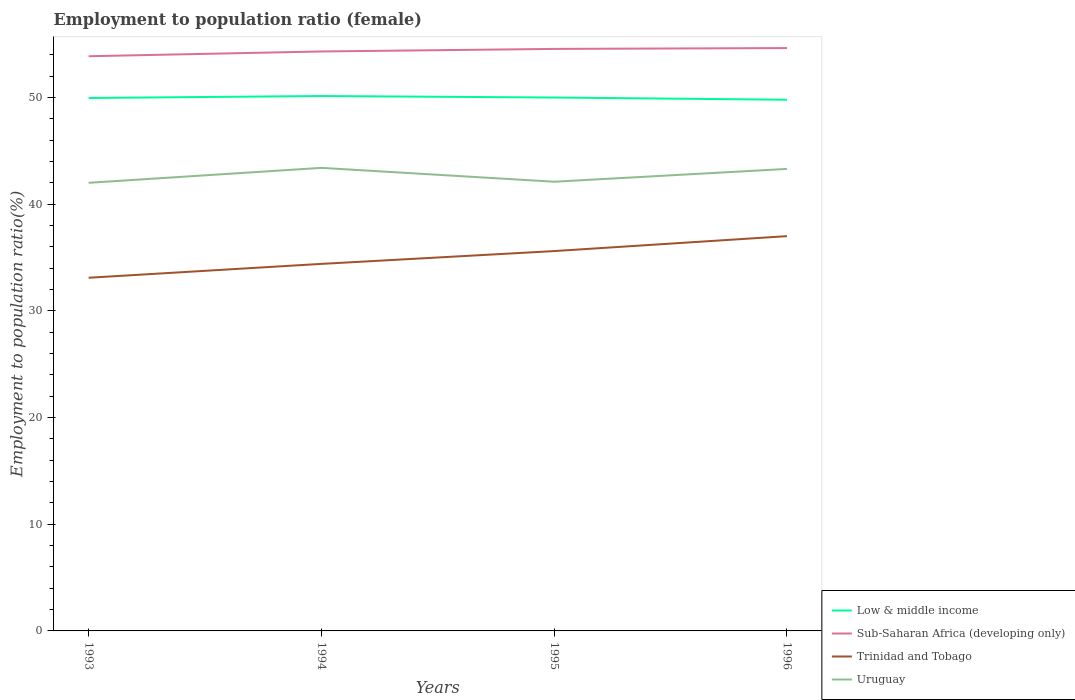Does the line corresponding to Sub-Saharan Africa (developing only) intersect with the line corresponding to Trinidad and Tobago?
Provide a short and direct response. No. Across all years, what is the maximum employment to population ratio in Trinidad and Tobago?
Your response must be concise. 33.1. What is the total employment to population ratio in Trinidad and Tobago in the graph?
Keep it short and to the point. -2.6. What is the difference between the highest and the second highest employment to population ratio in Uruguay?
Provide a succinct answer. 1.4. What is the difference between the highest and the lowest employment to population ratio in Sub-Saharan Africa (developing only)?
Your response must be concise. 2. What is the title of the graph?
Make the answer very short. Employment to population ratio (female). Does "Ukraine" appear as one of the legend labels in the graph?
Offer a very short reply. No. What is the label or title of the Y-axis?
Your answer should be compact. Employment to population ratio(%). What is the Employment to population ratio(%) of Low & middle income in 1993?
Ensure brevity in your answer.  49.95. What is the Employment to population ratio(%) of Sub-Saharan Africa (developing only) in 1993?
Give a very brief answer. 53.86. What is the Employment to population ratio(%) of Trinidad and Tobago in 1993?
Make the answer very short. 33.1. What is the Employment to population ratio(%) of Low & middle income in 1994?
Give a very brief answer. 50.13. What is the Employment to population ratio(%) of Sub-Saharan Africa (developing only) in 1994?
Your answer should be compact. 54.31. What is the Employment to population ratio(%) of Trinidad and Tobago in 1994?
Your response must be concise. 34.4. What is the Employment to population ratio(%) of Uruguay in 1994?
Keep it short and to the point. 43.4. What is the Employment to population ratio(%) in Low & middle income in 1995?
Your answer should be very brief. 49.99. What is the Employment to population ratio(%) of Sub-Saharan Africa (developing only) in 1995?
Keep it short and to the point. 54.55. What is the Employment to population ratio(%) in Trinidad and Tobago in 1995?
Offer a very short reply. 35.6. What is the Employment to population ratio(%) of Uruguay in 1995?
Provide a succinct answer. 42.1. What is the Employment to population ratio(%) of Low & middle income in 1996?
Offer a terse response. 49.79. What is the Employment to population ratio(%) of Sub-Saharan Africa (developing only) in 1996?
Provide a short and direct response. 54.63. What is the Employment to population ratio(%) in Trinidad and Tobago in 1996?
Ensure brevity in your answer.  37. What is the Employment to population ratio(%) in Uruguay in 1996?
Provide a short and direct response. 43.3. Across all years, what is the maximum Employment to population ratio(%) of Low & middle income?
Your answer should be very brief. 50.13. Across all years, what is the maximum Employment to population ratio(%) of Sub-Saharan Africa (developing only)?
Your answer should be compact. 54.63. Across all years, what is the maximum Employment to population ratio(%) of Trinidad and Tobago?
Your answer should be compact. 37. Across all years, what is the maximum Employment to population ratio(%) of Uruguay?
Your answer should be compact. 43.4. Across all years, what is the minimum Employment to population ratio(%) in Low & middle income?
Ensure brevity in your answer.  49.79. Across all years, what is the minimum Employment to population ratio(%) of Sub-Saharan Africa (developing only)?
Ensure brevity in your answer.  53.86. Across all years, what is the minimum Employment to population ratio(%) of Trinidad and Tobago?
Your response must be concise. 33.1. What is the total Employment to population ratio(%) of Low & middle income in the graph?
Keep it short and to the point. 199.86. What is the total Employment to population ratio(%) of Sub-Saharan Africa (developing only) in the graph?
Your answer should be very brief. 217.35. What is the total Employment to population ratio(%) of Trinidad and Tobago in the graph?
Offer a very short reply. 140.1. What is the total Employment to population ratio(%) of Uruguay in the graph?
Ensure brevity in your answer.  170.8. What is the difference between the Employment to population ratio(%) in Low & middle income in 1993 and that in 1994?
Give a very brief answer. -0.18. What is the difference between the Employment to population ratio(%) in Sub-Saharan Africa (developing only) in 1993 and that in 1994?
Give a very brief answer. -0.45. What is the difference between the Employment to population ratio(%) of Low & middle income in 1993 and that in 1995?
Your answer should be compact. -0.04. What is the difference between the Employment to population ratio(%) of Sub-Saharan Africa (developing only) in 1993 and that in 1995?
Your answer should be very brief. -0.69. What is the difference between the Employment to population ratio(%) in Low & middle income in 1993 and that in 1996?
Make the answer very short. 0.16. What is the difference between the Employment to population ratio(%) in Sub-Saharan Africa (developing only) in 1993 and that in 1996?
Keep it short and to the point. -0.77. What is the difference between the Employment to population ratio(%) of Trinidad and Tobago in 1993 and that in 1996?
Ensure brevity in your answer.  -3.9. What is the difference between the Employment to population ratio(%) in Low & middle income in 1994 and that in 1995?
Your answer should be compact. 0.14. What is the difference between the Employment to population ratio(%) in Sub-Saharan Africa (developing only) in 1994 and that in 1995?
Provide a short and direct response. -0.24. What is the difference between the Employment to population ratio(%) in Uruguay in 1994 and that in 1995?
Provide a succinct answer. 1.3. What is the difference between the Employment to population ratio(%) in Low & middle income in 1994 and that in 1996?
Offer a very short reply. 0.35. What is the difference between the Employment to population ratio(%) in Sub-Saharan Africa (developing only) in 1994 and that in 1996?
Your answer should be very brief. -0.32. What is the difference between the Employment to population ratio(%) of Uruguay in 1994 and that in 1996?
Offer a very short reply. 0.1. What is the difference between the Employment to population ratio(%) of Low & middle income in 1995 and that in 1996?
Your answer should be very brief. 0.21. What is the difference between the Employment to population ratio(%) in Sub-Saharan Africa (developing only) in 1995 and that in 1996?
Provide a succinct answer. -0.08. What is the difference between the Employment to population ratio(%) of Low & middle income in 1993 and the Employment to population ratio(%) of Sub-Saharan Africa (developing only) in 1994?
Keep it short and to the point. -4.36. What is the difference between the Employment to population ratio(%) in Low & middle income in 1993 and the Employment to population ratio(%) in Trinidad and Tobago in 1994?
Give a very brief answer. 15.55. What is the difference between the Employment to population ratio(%) of Low & middle income in 1993 and the Employment to population ratio(%) of Uruguay in 1994?
Your answer should be very brief. 6.55. What is the difference between the Employment to population ratio(%) of Sub-Saharan Africa (developing only) in 1993 and the Employment to population ratio(%) of Trinidad and Tobago in 1994?
Keep it short and to the point. 19.46. What is the difference between the Employment to population ratio(%) in Sub-Saharan Africa (developing only) in 1993 and the Employment to population ratio(%) in Uruguay in 1994?
Offer a terse response. 10.46. What is the difference between the Employment to population ratio(%) in Low & middle income in 1993 and the Employment to population ratio(%) in Sub-Saharan Africa (developing only) in 1995?
Your response must be concise. -4.6. What is the difference between the Employment to population ratio(%) of Low & middle income in 1993 and the Employment to population ratio(%) of Trinidad and Tobago in 1995?
Your response must be concise. 14.35. What is the difference between the Employment to population ratio(%) of Low & middle income in 1993 and the Employment to population ratio(%) of Uruguay in 1995?
Ensure brevity in your answer.  7.85. What is the difference between the Employment to population ratio(%) of Sub-Saharan Africa (developing only) in 1993 and the Employment to population ratio(%) of Trinidad and Tobago in 1995?
Offer a very short reply. 18.26. What is the difference between the Employment to population ratio(%) of Sub-Saharan Africa (developing only) in 1993 and the Employment to population ratio(%) of Uruguay in 1995?
Make the answer very short. 11.76. What is the difference between the Employment to population ratio(%) in Low & middle income in 1993 and the Employment to population ratio(%) in Sub-Saharan Africa (developing only) in 1996?
Make the answer very short. -4.68. What is the difference between the Employment to population ratio(%) of Low & middle income in 1993 and the Employment to population ratio(%) of Trinidad and Tobago in 1996?
Ensure brevity in your answer.  12.95. What is the difference between the Employment to population ratio(%) of Low & middle income in 1993 and the Employment to population ratio(%) of Uruguay in 1996?
Your answer should be compact. 6.65. What is the difference between the Employment to population ratio(%) in Sub-Saharan Africa (developing only) in 1993 and the Employment to population ratio(%) in Trinidad and Tobago in 1996?
Your answer should be compact. 16.86. What is the difference between the Employment to population ratio(%) in Sub-Saharan Africa (developing only) in 1993 and the Employment to population ratio(%) in Uruguay in 1996?
Your response must be concise. 10.56. What is the difference between the Employment to population ratio(%) of Trinidad and Tobago in 1993 and the Employment to population ratio(%) of Uruguay in 1996?
Your response must be concise. -10.2. What is the difference between the Employment to population ratio(%) in Low & middle income in 1994 and the Employment to population ratio(%) in Sub-Saharan Africa (developing only) in 1995?
Your response must be concise. -4.42. What is the difference between the Employment to population ratio(%) in Low & middle income in 1994 and the Employment to population ratio(%) in Trinidad and Tobago in 1995?
Your answer should be very brief. 14.53. What is the difference between the Employment to population ratio(%) in Low & middle income in 1994 and the Employment to population ratio(%) in Uruguay in 1995?
Make the answer very short. 8.03. What is the difference between the Employment to population ratio(%) of Sub-Saharan Africa (developing only) in 1994 and the Employment to population ratio(%) of Trinidad and Tobago in 1995?
Your answer should be very brief. 18.71. What is the difference between the Employment to population ratio(%) in Sub-Saharan Africa (developing only) in 1994 and the Employment to population ratio(%) in Uruguay in 1995?
Provide a short and direct response. 12.21. What is the difference between the Employment to population ratio(%) of Low & middle income in 1994 and the Employment to population ratio(%) of Sub-Saharan Africa (developing only) in 1996?
Provide a succinct answer. -4.49. What is the difference between the Employment to population ratio(%) of Low & middle income in 1994 and the Employment to population ratio(%) of Trinidad and Tobago in 1996?
Keep it short and to the point. 13.13. What is the difference between the Employment to population ratio(%) in Low & middle income in 1994 and the Employment to population ratio(%) in Uruguay in 1996?
Ensure brevity in your answer.  6.83. What is the difference between the Employment to population ratio(%) of Sub-Saharan Africa (developing only) in 1994 and the Employment to population ratio(%) of Trinidad and Tobago in 1996?
Your answer should be very brief. 17.31. What is the difference between the Employment to population ratio(%) in Sub-Saharan Africa (developing only) in 1994 and the Employment to population ratio(%) in Uruguay in 1996?
Offer a terse response. 11.01. What is the difference between the Employment to population ratio(%) in Trinidad and Tobago in 1994 and the Employment to population ratio(%) in Uruguay in 1996?
Offer a very short reply. -8.9. What is the difference between the Employment to population ratio(%) of Low & middle income in 1995 and the Employment to population ratio(%) of Sub-Saharan Africa (developing only) in 1996?
Your response must be concise. -4.63. What is the difference between the Employment to population ratio(%) of Low & middle income in 1995 and the Employment to population ratio(%) of Trinidad and Tobago in 1996?
Offer a terse response. 12.99. What is the difference between the Employment to population ratio(%) in Low & middle income in 1995 and the Employment to population ratio(%) in Uruguay in 1996?
Ensure brevity in your answer.  6.69. What is the difference between the Employment to population ratio(%) in Sub-Saharan Africa (developing only) in 1995 and the Employment to population ratio(%) in Trinidad and Tobago in 1996?
Your answer should be compact. 17.55. What is the difference between the Employment to population ratio(%) of Sub-Saharan Africa (developing only) in 1995 and the Employment to population ratio(%) of Uruguay in 1996?
Your answer should be compact. 11.25. What is the difference between the Employment to population ratio(%) in Trinidad and Tobago in 1995 and the Employment to population ratio(%) in Uruguay in 1996?
Your answer should be compact. -7.7. What is the average Employment to population ratio(%) of Low & middle income per year?
Make the answer very short. 49.97. What is the average Employment to population ratio(%) of Sub-Saharan Africa (developing only) per year?
Your answer should be compact. 54.34. What is the average Employment to population ratio(%) of Trinidad and Tobago per year?
Make the answer very short. 35.02. What is the average Employment to population ratio(%) in Uruguay per year?
Your answer should be very brief. 42.7. In the year 1993, what is the difference between the Employment to population ratio(%) in Low & middle income and Employment to population ratio(%) in Sub-Saharan Africa (developing only)?
Provide a succinct answer. -3.91. In the year 1993, what is the difference between the Employment to population ratio(%) of Low & middle income and Employment to population ratio(%) of Trinidad and Tobago?
Your response must be concise. 16.85. In the year 1993, what is the difference between the Employment to population ratio(%) of Low & middle income and Employment to population ratio(%) of Uruguay?
Provide a short and direct response. 7.95. In the year 1993, what is the difference between the Employment to population ratio(%) in Sub-Saharan Africa (developing only) and Employment to population ratio(%) in Trinidad and Tobago?
Give a very brief answer. 20.76. In the year 1993, what is the difference between the Employment to population ratio(%) of Sub-Saharan Africa (developing only) and Employment to population ratio(%) of Uruguay?
Keep it short and to the point. 11.86. In the year 1993, what is the difference between the Employment to population ratio(%) in Trinidad and Tobago and Employment to population ratio(%) in Uruguay?
Provide a short and direct response. -8.9. In the year 1994, what is the difference between the Employment to population ratio(%) of Low & middle income and Employment to population ratio(%) of Sub-Saharan Africa (developing only)?
Your answer should be very brief. -4.18. In the year 1994, what is the difference between the Employment to population ratio(%) in Low & middle income and Employment to population ratio(%) in Trinidad and Tobago?
Provide a succinct answer. 15.73. In the year 1994, what is the difference between the Employment to population ratio(%) of Low & middle income and Employment to population ratio(%) of Uruguay?
Offer a terse response. 6.73. In the year 1994, what is the difference between the Employment to population ratio(%) in Sub-Saharan Africa (developing only) and Employment to population ratio(%) in Trinidad and Tobago?
Provide a succinct answer. 19.91. In the year 1994, what is the difference between the Employment to population ratio(%) in Sub-Saharan Africa (developing only) and Employment to population ratio(%) in Uruguay?
Provide a succinct answer. 10.91. In the year 1994, what is the difference between the Employment to population ratio(%) in Trinidad and Tobago and Employment to population ratio(%) in Uruguay?
Your answer should be compact. -9. In the year 1995, what is the difference between the Employment to population ratio(%) of Low & middle income and Employment to population ratio(%) of Sub-Saharan Africa (developing only)?
Your answer should be compact. -4.56. In the year 1995, what is the difference between the Employment to population ratio(%) in Low & middle income and Employment to population ratio(%) in Trinidad and Tobago?
Offer a very short reply. 14.39. In the year 1995, what is the difference between the Employment to population ratio(%) of Low & middle income and Employment to population ratio(%) of Uruguay?
Give a very brief answer. 7.89. In the year 1995, what is the difference between the Employment to population ratio(%) of Sub-Saharan Africa (developing only) and Employment to population ratio(%) of Trinidad and Tobago?
Ensure brevity in your answer.  18.95. In the year 1995, what is the difference between the Employment to population ratio(%) of Sub-Saharan Africa (developing only) and Employment to population ratio(%) of Uruguay?
Provide a succinct answer. 12.45. In the year 1995, what is the difference between the Employment to population ratio(%) in Trinidad and Tobago and Employment to population ratio(%) in Uruguay?
Your answer should be very brief. -6.5. In the year 1996, what is the difference between the Employment to population ratio(%) in Low & middle income and Employment to population ratio(%) in Sub-Saharan Africa (developing only)?
Your answer should be very brief. -4.84. In the year 1996, what is the difference between the Employment to population ratio(%) of Low & middle income and Employment to population ratio(%) of Trinidad and Tobago?
Give a very brief answer. 12.79. In the year 1996, what is the difference between the Employment to population ratio(%) in Low & middle income and Employment to population ratio(%) in Uruguay?
Keep it short and to the point. 6.49. In the year 1996, what is the difference between the Employment to population ratio(%) of Sub-Saharan Africa (developing only) and Employment to population ratio(%) of Trinidad and Tobago?
Provide a succinct answer. 17.63. In the year 1996, what is the difference between the Employment to population ratio(%) in Sub-Saharan Africa (developing only) and Employment to population ratio(%) in Uruguay?
Make the answer very short. 11.33. In the year 1996, what is the difference between the Employment to population ratio(%) of Trinidad and Tobago and Employment to population ratio(%) of Uruguay?
Offer a terse response. -6.3. What is the ratio of the Employment to population ratio(%) of Low & middle income in 1993 to that in 1994?
Offer a very short reply. 1. What is the ratio of the Employment to population ratio(%) in Trinidad and Tobago in 1993 to that in 1994?
Your answer should be compact. 0.96. What is the ratio of the Employment to population ratio(%) in Uruguay in 1993 to that in 1994?
Keep it short and to the point. 0.97. What is the ratio of the Employment to population ratio(%) of Sub-Saharan Africa (developing only) in 1993 to that in 1995?
Your answer should be compact. 0.99. What is the ratio of the Employment to population ratio(%) in Trinidad and Tobago in 1993 to that in 1995?
Provide a succinct answer. 0.93. What is the ratio of the Employment to population ratio(%) in Low & middle income in 1993 to that in 1996?
Make the answer very short. 1. What is the ratio of the Employment to population ratio(%) of Trinidad and Tobago in 1993 to that in 1996?
Provide a short and direct response. 0.89. What is the ratio of the Employment to population ratio(%) in Sub-Saharan Africa (developing only) in 1994 to that in 1995?
Give a very brief answer. 1. What is the ratio of the Employment to population ratio(%) of Trinidad and Tobago in 1994 to that in 1995?
Provide a short and direct response. 0.97. What is the ratio of the Employment to population ratio(%) in Uruguay in 1994 to that in 1995?
Offer a very short reply. 1.03. What is the ratio of the Employment to population ratio(%) of Trinidad and Tobago in 1994 to that in 1996?
Provide a short and direct response. 0.93. What is the ratio of the Employment to population ratio(%) in Low & middle income in 1995 to that in 1996?
Your answer should be very brief. 1. What is the ratio of the Employment to population ratio(%) in Trinidad and Tobago in 1995 to that in 1996?
Make the answer very short. 0.96. What is the ratio of the Employment to population ratio(%) of Uruguay in 1995 to that in 1996?
Your answer should be compact. 0.97. What is the difference between the highest and the second highest Employment to population ratio(%) of Low & middle income?
Provide a short and direct response. 0.14. What is the difference between the highest and the second highest Employment to population ratio(%) of Sub-Saharan Africa (developing only)?
Provide a short and direct response. 0.08. What is the difference between the highest and the second highest Employment to population ratio(%) in Trinidad and Tobago?
Your answer should be compact. 1.4. What is the difference between the highest and the second highest Employment to population ratio(%) in Uruguay?
Offer a terse response. 0.1. What is the difference between the highest and the lowest Employment to population ratio(%) in Low & middle income?
Offer a terse response. 0.35. What is the difference between the highest and the lowest Employment to population ratio(%) of Sub-Saharan Africa (developing only)?
Provide a succinct answer. 0.77. What is the difference between the highest and the lowest Employment to population ratio(%) in Trinidad and Tobago?
Provide a short and direct response. 3.9. 